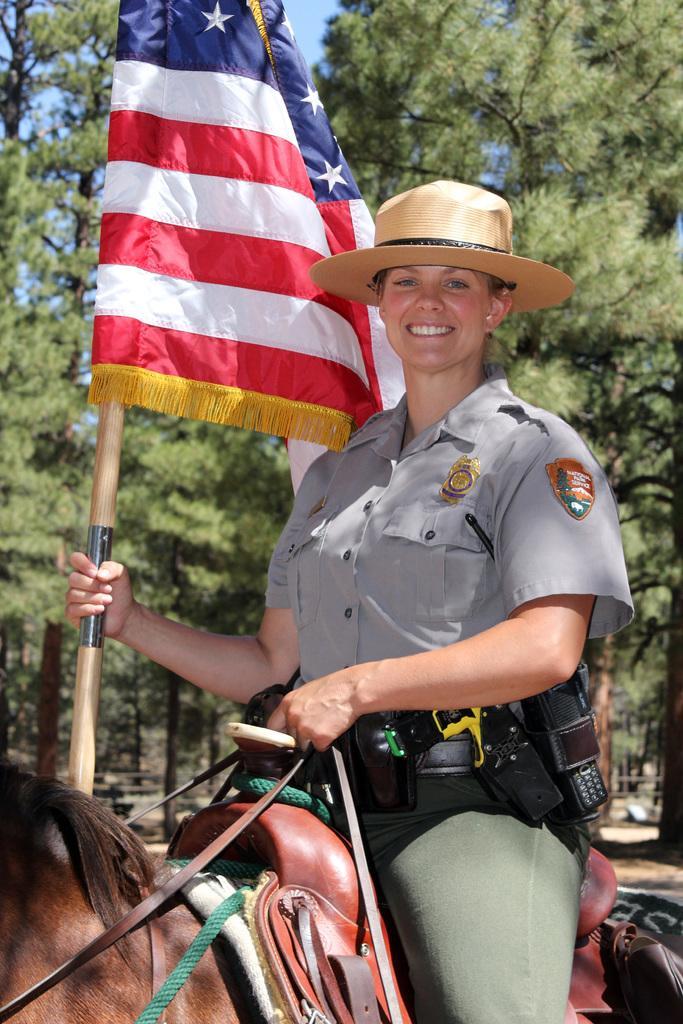In one or two sentences, can you explain what this image depicts? To the bottom of the image there is a horse with few items on it. On the horse there is a lady with grey shirt is sitting on the horse and she is holding the flag pole in her hands. In the background there are trees. 